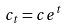<formula> <loc_0><loc_0><loc_500><loc_500>c _ { t } = c e ^ { t }</formula> 